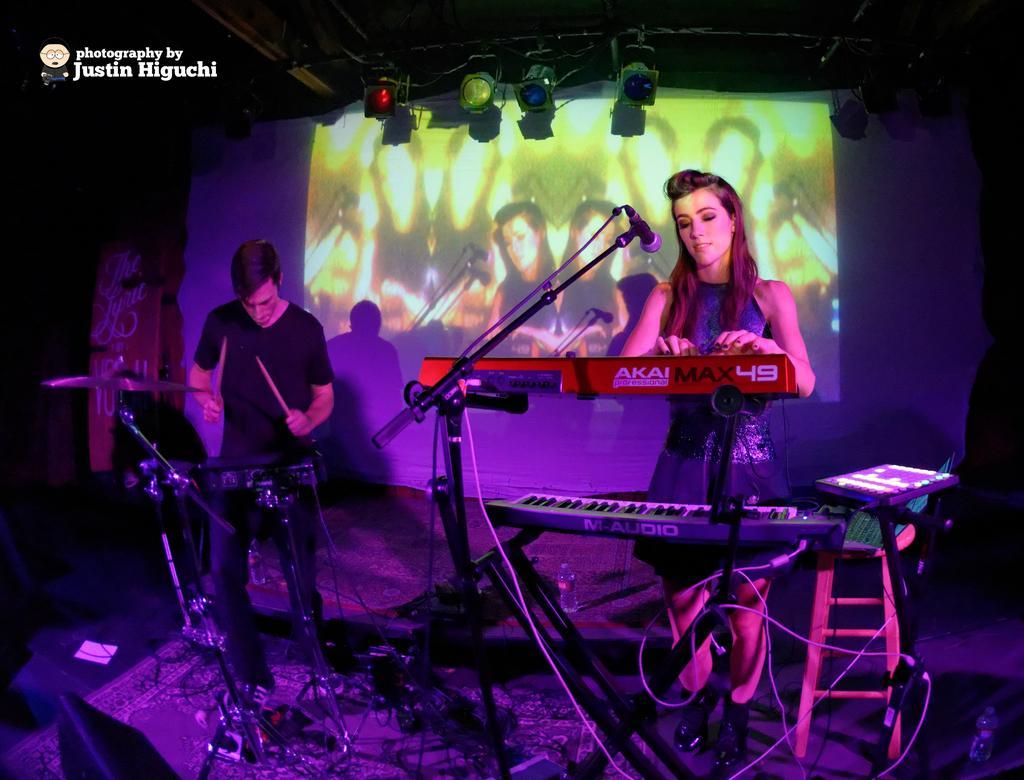Could you give a brief overview of what you see in this image? This picture shows a woman standing and playing piano and we see a microphone and we see another man standing and holding two sticks in his hands and playing an instrument and we see water bottle and another piano and a stool on the dais and we see a projector screen and few lights hanging to the roof and we see text on the top left corner. 